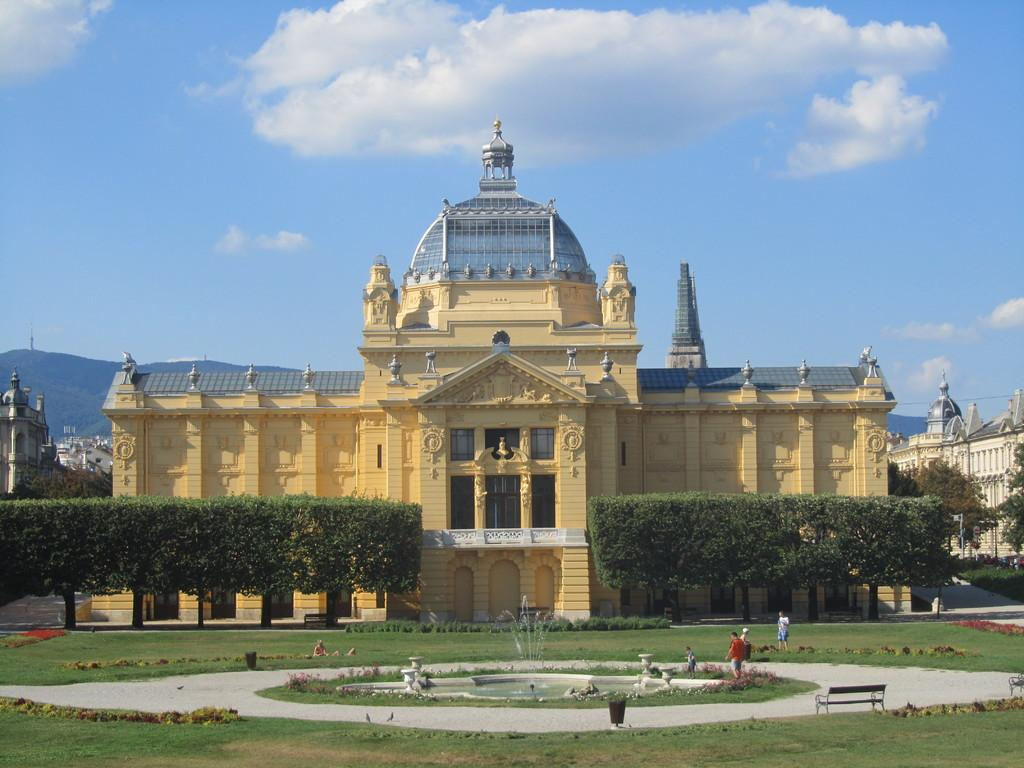What can be seen in the sky in the image? The sky is visible in the image, and clouds are present. What type of natural features can be seen in the image? Hills are visible in the image, along with trees and grass. What type of structures can be seen in the image? Buildings are visible in the image. What are the people in the image doing? There are people in the image, but their activities are not specified. What is the focal point of the image? There is a fountain in the image, which may be the focal point. Are there any other objects in the image? Yes, there are a few other objects in the image, but their specifics are not mentioned. What type of jelly is being used to conduct a science experiment in the image? There is no jelly or science experiment present in the image. What type of knife is being used to cut the grass in the image? There is no knife or grass-cutting activity depicted in the image. 